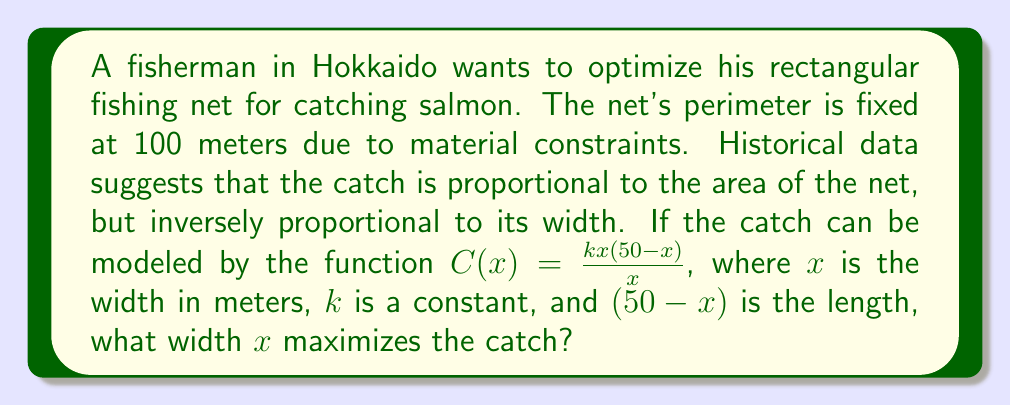Solve this math problem. To find the optimal width, we need to maximize the catch function $C(x)$:

1) Simplify the catch function:
   $C(x) = \frac{kx(50-x)}{x} = k(50-x)$

2) To find the maximum, differentiate $C(x)$ with respect to $x$:
   $\frac{dC}{dx} = -k$

3) Set the derivative to zero to find critical points:
   $-k = 0$

4) This equation has no solution, meaning there are no critical points in the interior of the domain.

5) Check the endpoints of the domain. The width $x$ must be positive and less than 50 (half the perimeter):
   At $x = 0$: $C(0) = k(50-0) = 50k$
   As $x$ approaches 50: $C(50) = k(50-50) = 0$

6) Since $C(x)$ decreases linearly from $50k$ to 0 as $x$ goes from 0 to 50, the maximum occurs at the smallest possible positive value of $x$.

7) In practice, the net needs a non-zero width. Let $\epsilon$ be the minimum practical width. The optimal width is then $x = \epsilon$.
Answer: $x = \epsilon$, where $\epsilon$ is the minimum practical width. 